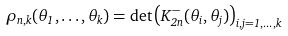Convert formula to latex. <formula><loc_0><loc_0><loc_500><loc_500>\rho _ { n , k } ( \theta _ { 1 } , \dots , \theta _ { k } ) = \det \left ( K ^ { - } _ { 2 n } ( \theta _ { i } , \theta _ { j } ) \right ) _ { i , j = 1 , \dots , k }</formula> 